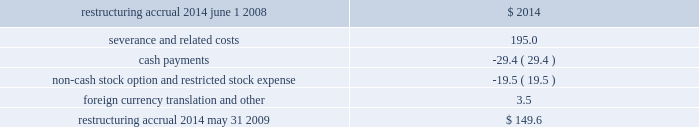Nike , inc .
Notes to consolidated financial statements 2014 ( continued ) such agreements in place .
However , based on the company 2019s historical experience and the estimated probability of future loss , the company has determined that the fair value of such indemnifications is not material to the company 2019s financial position or results of operations .
In the ordinary course of its business , the company is involved in various legal proceedings involving contractual and employment relationships , product liability claims , trademark rights , and a variety of other matters .
The company does not believe there are any pending legal proceedings that will have a material impact on the company 2019s financial position or results of operations .
Note 16 2014 restructuring charges during the fourth quarter of fiscal 2009 , the company took necessary steps to streamline its management structure , enhance consumer focus , drive innovation more quickly to market and establish a more scalable , long-term cost structure .
As a result , the company reduced its global workforce by approximately 5% ( 5 % ) and incurred pre-tax restructuring charges of $ 195 million , primarily consisting of severance costs related to the workforce reduction .
As nearly all of the restructuring activities were completed in the fourth quarter of fiscal 2009 , the company does not expect to recognize additional costs in future periods relating to these actions .
The restructuring charge is reflected in the corporate expense line in the segment presentation of pre-tax income in note 19 2014 operating segments and related information .
The activity in the restructuring accrual for the year ended may 31 , 2009 is as follows ( in millions ) : .
The accrual balance as of may 31 , 2009 will be relieved throughout fiscal year 2010 and early 2011 , as severance payments are completed .
The restructuring accrual is included in accrued liabilities in the consolidated balance sheet .
As part of its restructuring activities , the company reorganized its nike brand operations geographic structure .
In fiscal 2009 , 2008 and 2007 , nike brand operations were organized into the following four geographic regions : u.s. , europe , middle east and africa ( collectively , 201cemea 201d ) , asia pacific , and americas .
In the fourth quarter of 2009 , the company initiated a reorganization of the nike brand business into a new operating model .
As a result of this reorganization , beginning in the first quarter of fiscal 2010 , the nike brand operations will consist of the following six geographies : north america , western europe , central/eastern europe , greater china , japan , and emerging markets .
Note 17 2014 divestitures on december 17 , 2007 , the company completed the sale of the starter brand business to iconix brand group , inc .
For $ 60.0 million in cash .
This transaction resulted in a gain of $ 28.6 million during the year ended may 31 , 2008. .
What was the percentage gain on the sale of starter brand business? 
Computations: (28.6 / (60.0 - 28.6))
Answer: 0.91083. 